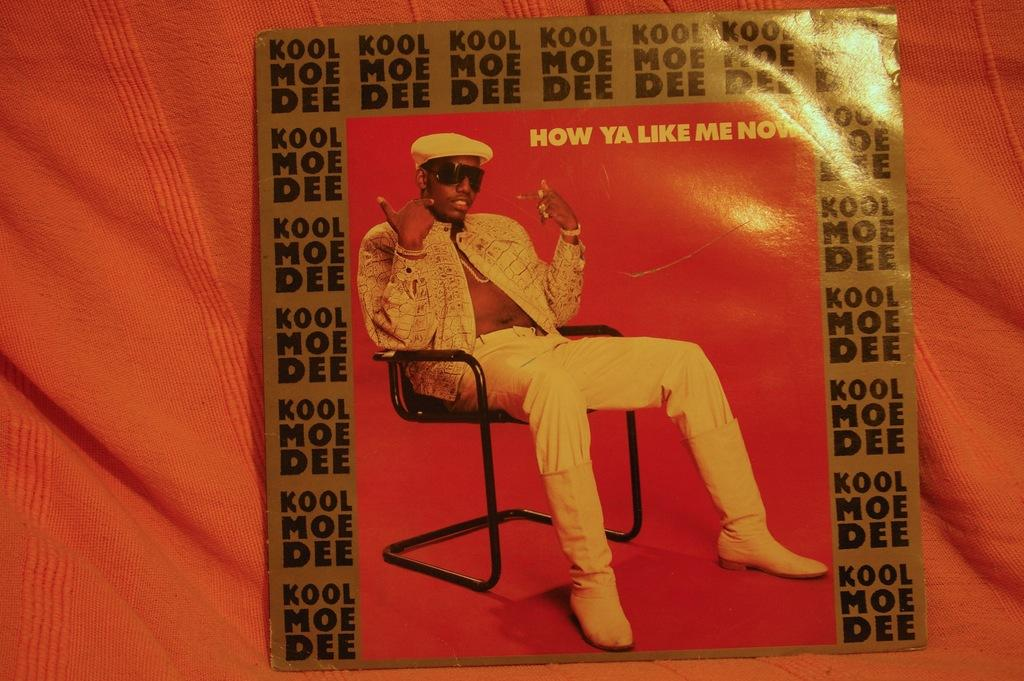What is the main object in the image? There is a sheet in the image. What is the sheet placed on? The sheet is placed on a cloth. What else can be seen in the image? There is an image of a man in the image. What is the man doing in the image? The man is sitting on a chair in the image. Are there any giants visible in the image? No, there are no giants present in the image. What type of furniture can be seen in the image besides the chair? There is no other furniture visible in the image besides the chair. 